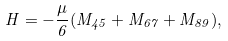Convert formula to latex. <formula><loc_0><loc_0><loc_500><loc_500>H = - \frac { \mu } { 6 } ( M _ { 4 5 } + M _ { 6 7 } + M _ { 8 9 } ) ,</formula> 